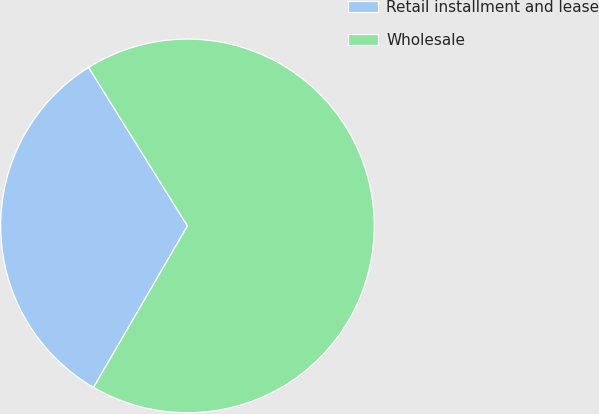Convert chart to OTSL. <chart><loc_0><loc_0><loc_500><loc_500><pie_chart><fcel>Retail installment and lease<fcel>Wholesale<nl><fcel>32.74%<fcel>67.26%<nl></chart> 